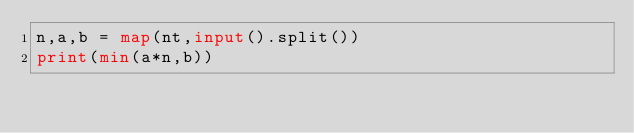Convert code to text. <code><loc_0><loc_0><loc_500><loc_500><_Python_>n,a,b = map(nt,input().split())
print(min(a*n,b))</code> 